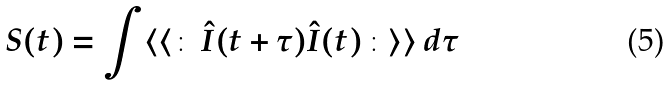<formula> <loc_0><loc_0><loc_500><loc_500>S ( t ) = \int \langle \langle \colon \, \hat { I } ( t + \tau ) \hat { I } ( t ) \, \colon \rangle \rangle \, d \tau</formula> 